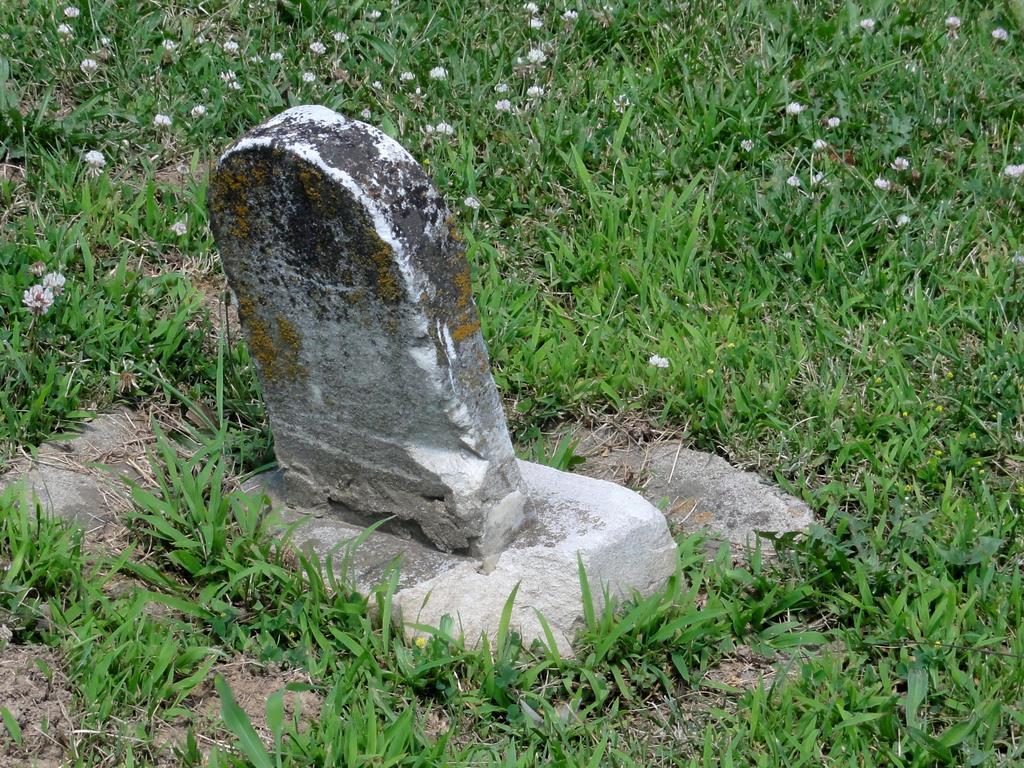How would you summarize this image in a sentence or two? In this image there is grass on the ground and there is a stone in the center and on the grass there are flowers which are white in colour. 